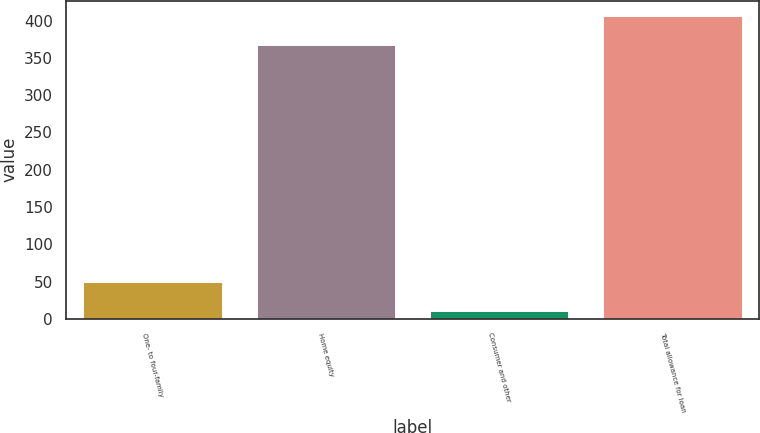Convert chart to OTSL. <chart><loc_0><loc_0><loc_500><loc_500><bar_chart><fcel>One- to four-family<fcel>Home equity<fcel>Consumer and other<fcel>Total allowance for loan<nl><fcel>49.4<fcel>367<fcel>10<fcel>406.4<nl></chart> 